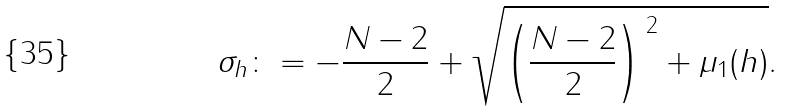Convert formula to latex. <formula><loc_0><loc_0><loc_500><loc_500>\sigma _ { h } \colon = - \frac { N - 2 } 2 + \sqrt { \left ( \frac { N - 2 } 2 \right ) ^ { \, 2 } + \mu _ { 1 } ( h ) } .</formula> 